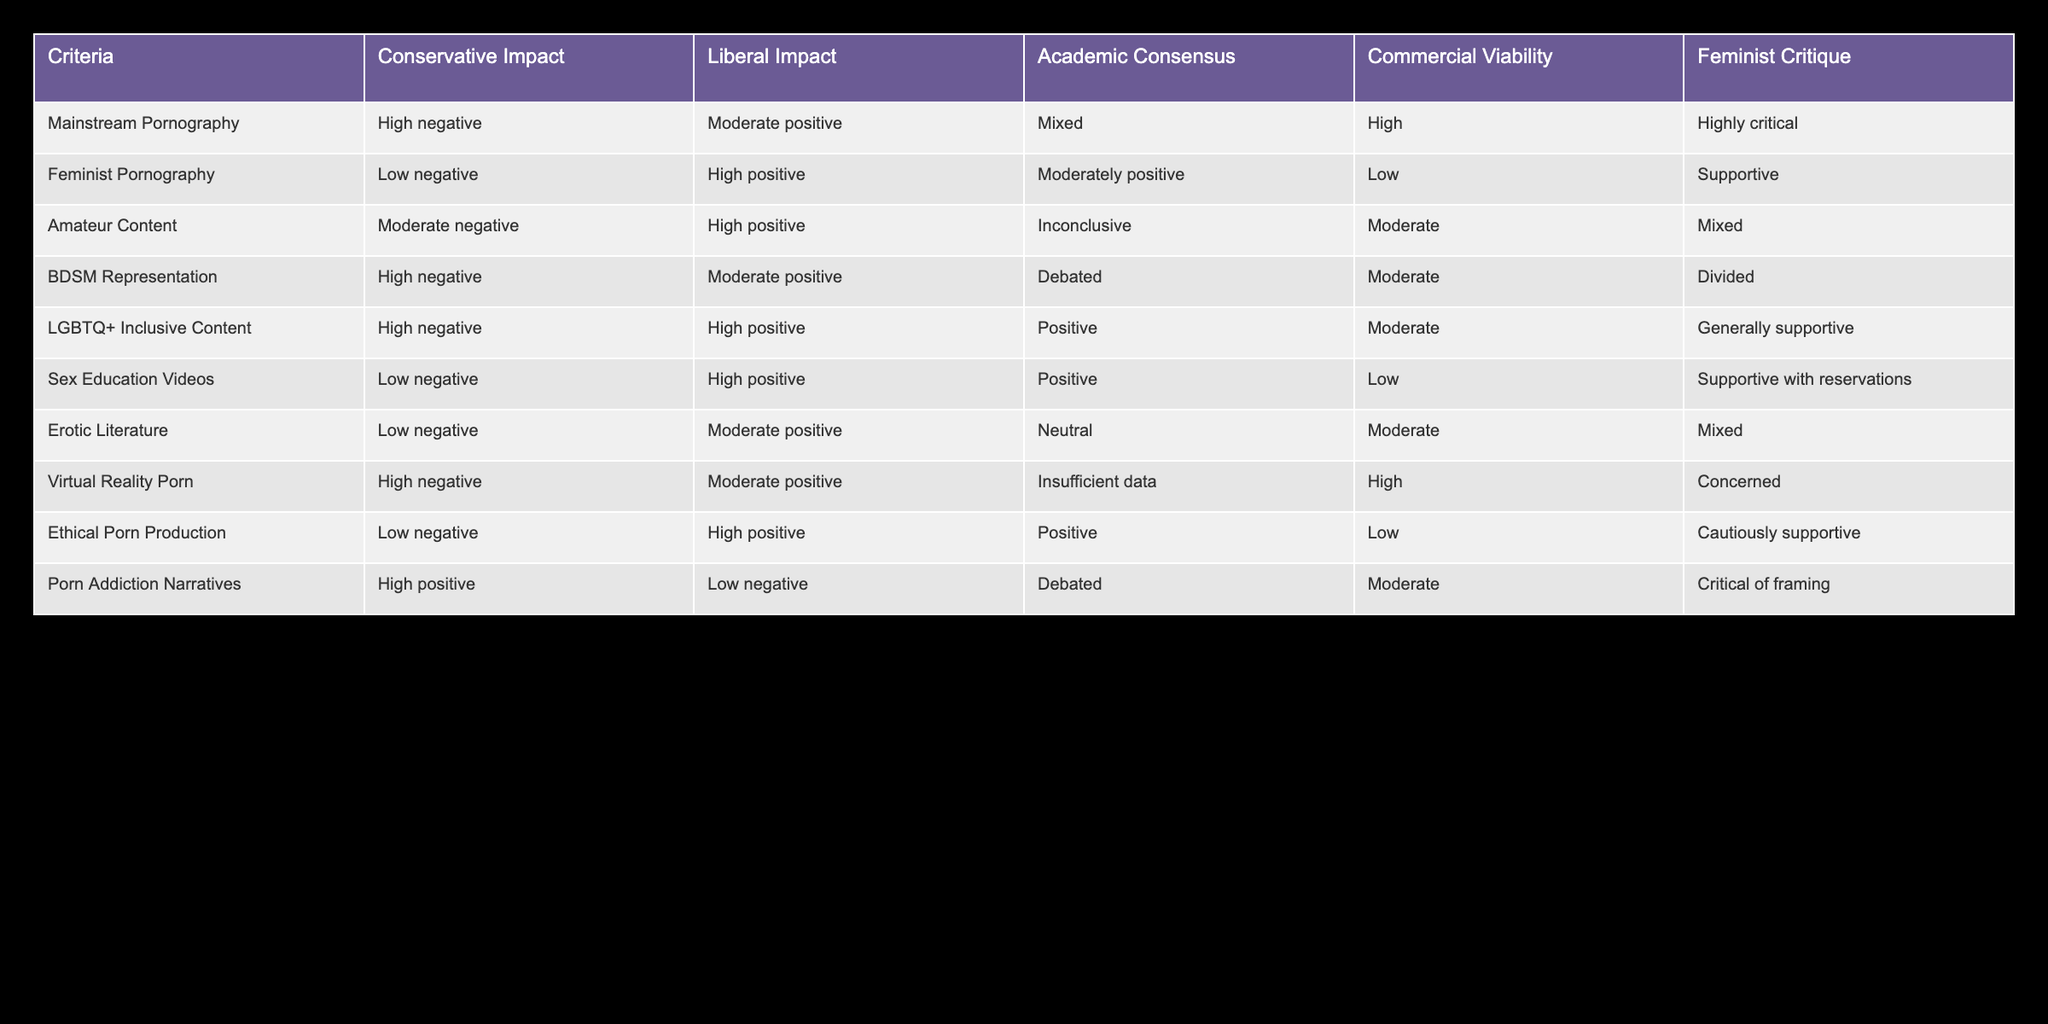What's the impact of "Mainstream Pornography" on conservative views? The table shows that the conservative impact of "Mainstream Pornography" is categorized as "High negative".
Answer: High negative Which category has a "Low negative" impact on conservative views and a "High positive" impact on liberal views? The category "Feminist Pornography" has a "Low negative" impact on conservative views and a "High positive" impact on liberal views, as specified in the table.
Answer: Feminist Pornography What is the academic consensus regarding "Sex Education Videos"? The table indicates that the academic consensus on "Sex Education Videos" is "Positive".
Answer: Positive Is the impact of "BDSM Representation" on conservative views positive? The data in the table states that "BDSM Representation" has a "High negative" impact on conservative views, so the answer is no.
Answer: No What category has a "High positive" impact on liberal views but an "Inconclusive" academic consensus? According to the table, "Amateur Content" has a "High positive" impact on liberal views while having an "Inconclusive" academic consensus.
Answer: Amateur Content How does the "Commercial Viability" of "Ethical Porn Production" compare with that of "Virtual Reality Porn"? The table states that "Ethical Porn Production" has "Low" commercial viability, while "Virtual Reality Porn" has "High" commercial viability. Therefore, "Virtual Reality Porn" is more commercially viable than "Ethical Porn Production".
Answer: More viable Which category shows a mixed critique from feminists? The table indicates that "Amateur Content" and "Erotic Literature" both receive a "Mixed" critique from feminists.
Answer: Amateur Content, Erotic Literature What is the overall trend regarding the liberal impact across categories? By analyzing the liberal impact across categories, most of them show either a "High positive" or "Moderate positive" impact, suggesting a prevalent trend towards a positive liberal view.
Answer: Positive trend 